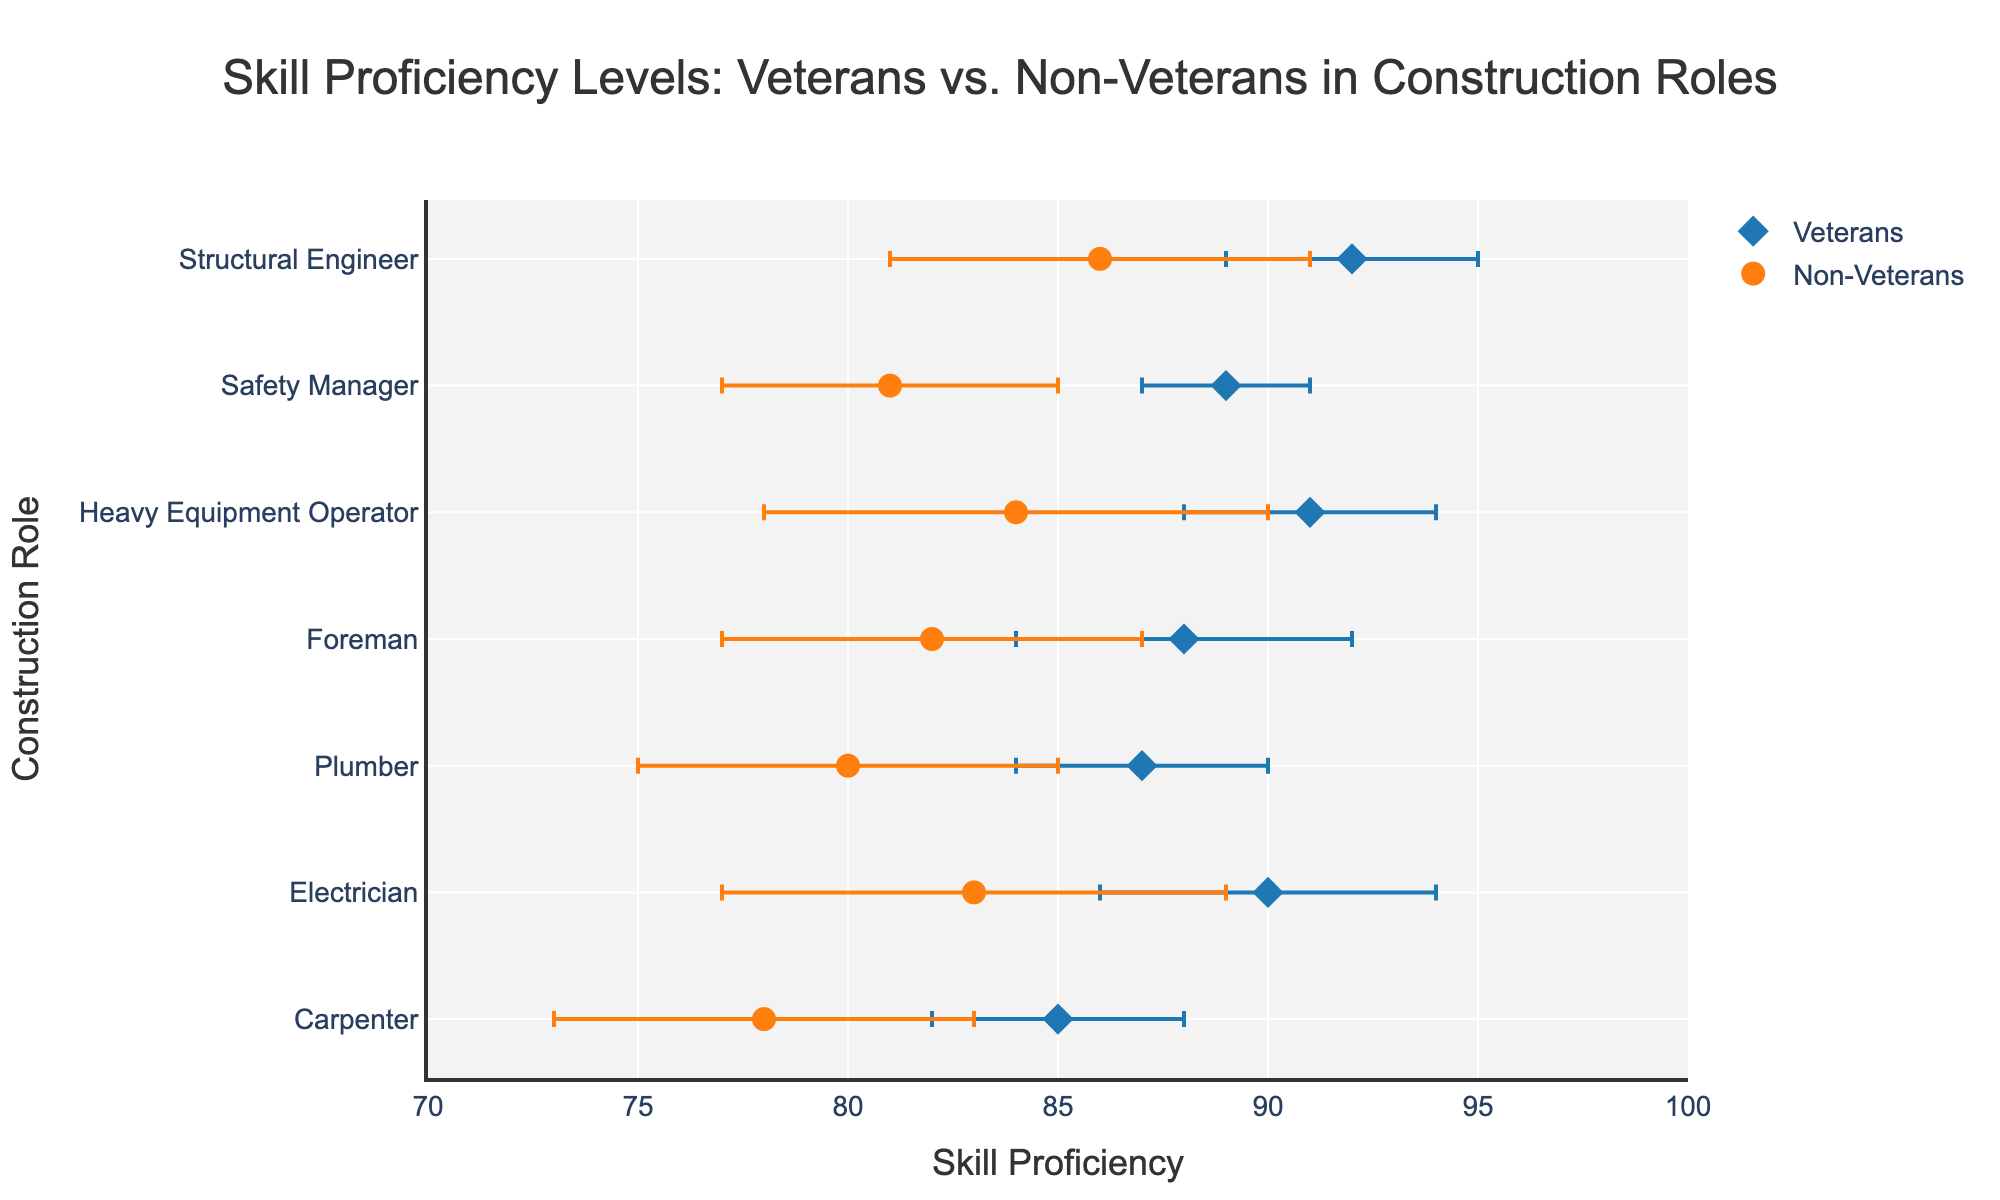What is the title of the plot? The title is placed prominently at the top of the plot, and it is "Skill Proficiency Levels: Veterans vs. Non-Veterans in Construction Roles".
Answer: Skill Proficiency Levels: Veterans vs. Non-Veterans in Construction Roles How many roles are compared in the plot? Each unique role is represented on the y-axis, with each role shown for both veterans and non-veterans. Counting these roles will give us the total number of roles compared.
Answer: 7 Which group has a higher skill proficiency level for the role of Electrician? By observing the x-axis positions of the dots corresponding to the "Electrician" role, we compare the skill proficiency levels of veterans and non-veterans.
Answer: Veterans What is the average skill proficiency level for veterans across all roles? There are 7 roles, each with a skill proficiency level for veterans. Summing these values (85 + 90 + 87 + 88 + 91 + 89 + 92) and dividing by 7 provides the average.
Answer: 88.86 Which role shows the largest difference in skill proficiency between veterans and non-veterans? To find this, calculate the difference in skill proficiency for each role and identify the largest difference. For example: Electrician (90 - 83 = 7), compare all roles similarly.
Answer: Heavy Equipment Operator What are the error bars indicating for each data point? Error bars in the plot mark variability or uncertainty in the proficiency levels, with the bar length indicating the magnitude of the error.
Answer: Variability/Uncertainty For the role of Carpenter, what is the skill proficiency range for non-veterans considering the error bars? Non-veterans' proficiency level is 78 with an error of 5: the range is from 78-5 to 78+5, i.e., 73 to 83.
Answer: 73 to 83 Which group has higher skill proficiency for the role of Safety Manager? By comparing the positions of the data points for the role of "Safety Manager", we find that veterans have a higher proficiency level.
Answer: Veterans What is the skill proficiency difference between veterans and non-veterans for the role of Foreman considering the error bars? Veterans' proficiency is 88 (±4) and non-veterans' is 82 (±5). We calculate the difference as 88 - 82 = 6. Error bars highlight possible range overlaps but don't affect the calculation of the difference based on central values.
Answer: 6 How do the skill proficiency levels of veterans as Safety Managers compare to those of non-veterans as Plumbers? Veterans' proficiency as Safety Managers is 89, and non-veterans' proficiency as Plumbers is 80. Comparing these values, we see veterans as Safety Managers have higher proficiency.
Answer: Veterans as Safety Managers 